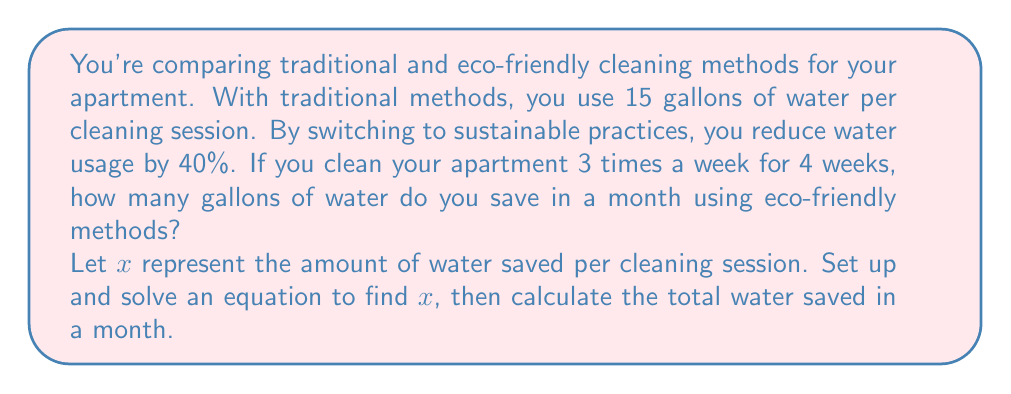Help me with this question. 1. Set up the equation:
   Traditional water usage - 40% reduction = New water usage
   $15 - 0.40(15) = 15 - x$

2. Solve for $x$:
   $15 - 6 = 15 - x$
   $9 = 15 - x$
   $x = 15 - 9 = 6$

   So, you save 6 gallons per cleaning session.

3. Calculate water saved in a month:
   Cleanings per week: 3
   Weeks in a month: 4
   Total cleanings: $3 \times 4 = 12$

   Water saved in a month: $12 \times 6 = 72$ gallons

Therefore, you save 72 gallons of water in a month using eco-friendly cleaning methods.
Answer: 72 gallons 